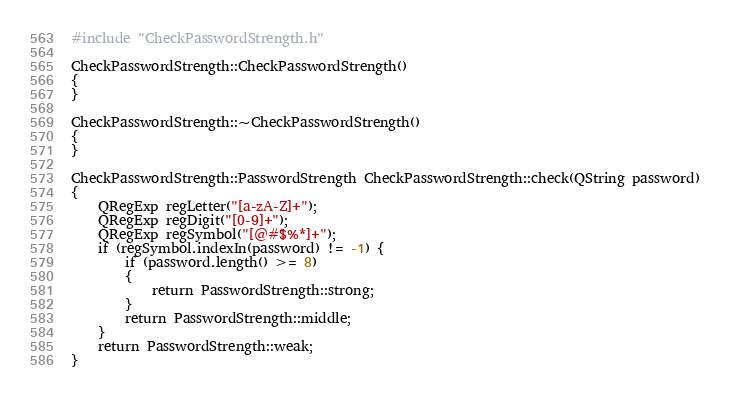Convert code to text. <code><loc_0><loc_0><loc_500><loc_500><_C++_>#include "CheckPasswordStrength.h"

CheckPasswordStrength::CheckPasswordStrength()
{
}

CheckPasswordStrength::~CheckPasswordStrength()
{
}

CheckPasswordStrength::PasswordStrength CheckPasswordStrength::check(QString password)
{
	QRegExp regLetter("[a-zA-Z]+");
	QRegExp regDigit("[0-9]+");
	QRegExp regSymbol("[@#$%*]+");
	if (regSymbol.indexIn(password) != -1) {
		if (password.length() >= 8)
		{
			return PasswordStrength::strong;
		}
		return PasswordStrength::middle;
	}
	return PasswordStrength::weak;
}
</code> 